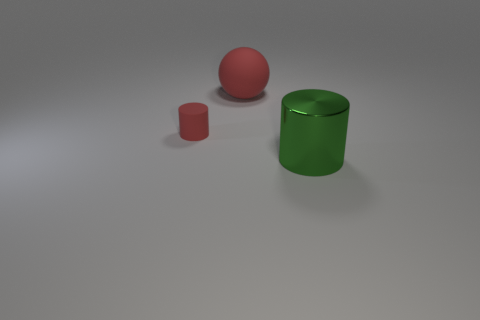Add 1 tiny red rubber cylinders. How many objects exist? 4 Subtract all cylinders. How many objects are left? 1 Subtract 0 cyan balls. How many objects are left? 3 Subtract all red matte cylinders. Subtract all red cylinders. How many objects are left? 1 Add 2 tiny rubber cylinders. How many tiny rubber cylinders are left? 3 Add 3 green cylinders. How many green cylinders exist? 4 